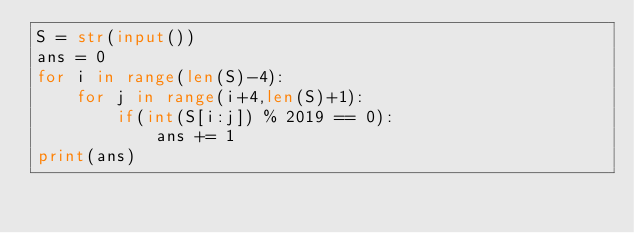Convert code to text. <code><loc_0><loc_0><loc_500><loc_500><_Python_>S = str(input())
ans = 0
for i in range(len(S)-4):
    for j in range(i+4,len(S)+1):
        if(int(S[i:j]) % 2019 == 0):
            ans += 1
print(ans)</code> 